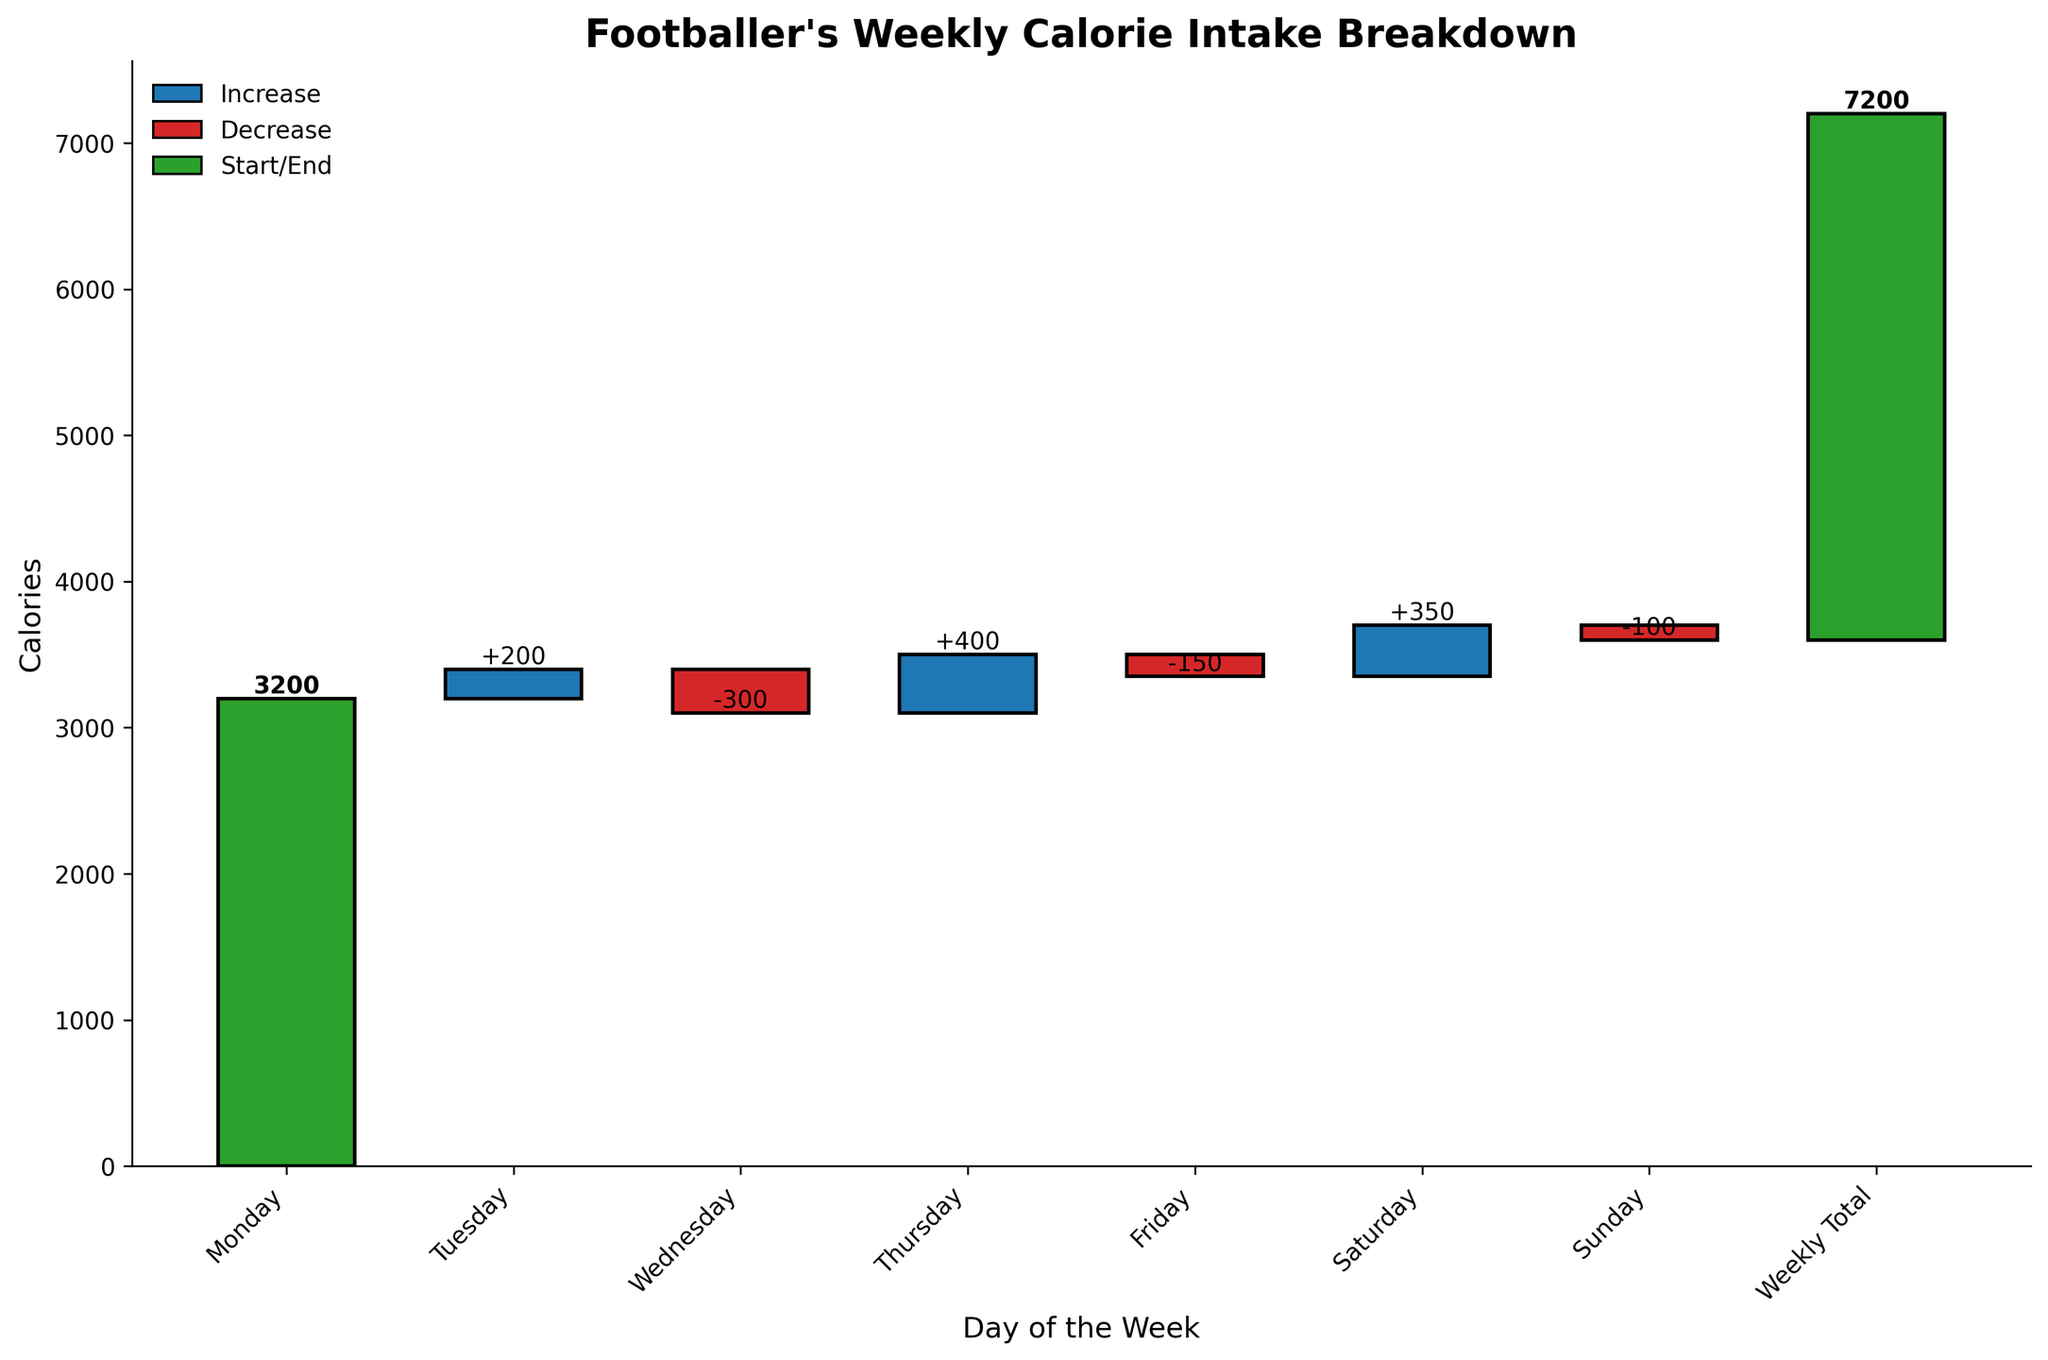What is the title of the chart? The title is located at the top of the chart and usually describes the main topic or data being visualized.
Answer: Footballer's Weekly Calorie Intake Breakdown Which color represents the 'Increase' in calories? The color legend in the chart indicates that blue is used to represent an increase in calorie intake.
Answer: Blue On which day did the footballer consume the highest number of additional calories compared to the previous day? By looking at the height of the bars representing increases, Thursday has the highest increase with 400 calories.
Answer: Thursday What is the total calorie increase over the week? To find the total increase, sum all the positive values: 200 (Tuesday) + 400 (Thursday) + 350 (Saturday) = 950
Answer: 950 What is the cumulative calorie intake by the end of Wednesday? Starting from Monday's 3200, add Tuesday's 200 and subtract Wednesday's 300: 3200 + 200 - 300 = 3100
Answer: 3100 Which day had the largest decrease in calorie intake? The largest decrease bar can be seen on Wednesday at -300 calories.
Answer: Wednesday What was the calorie intake difference between Thursday and Friday? The difference between Thursday's increase of 400 and Friday's decrease of 150 is 400 - 150 = 250
Answer: 250 By how many calories does the weekly total exceed Monday's initial calorie intake? The cumulative on Monday is 3200, and the weekly total is 3600. So, 3600 - 3200 = 400 calories.
Answer: 400 Which day had a lower calorie fluctuation, Tuesday or Friday? Tuesday had an increase of 200 calories, whereas Friday had a decrease of 150 calories.
Answer: Friday 